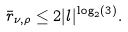Convert formula to latex. <formula><loc_0><loc_0><loc_500><loc_500>\bar { r } _ { \nu , \rho } \leq 2 | l | ^ { \log _ { 2 } ( 3 ) } .</formula> 